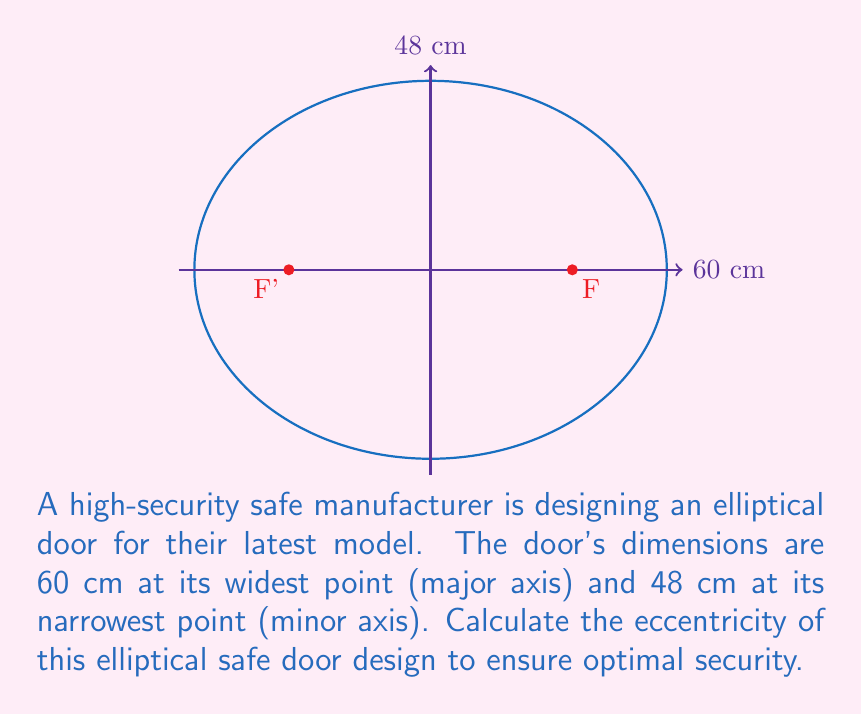Could you help me with this problem? Let's approach this step-by-step:

1) The eccentricity of an ellipse is given by the formula:

   $$e = \frac{\sqrt{a^2 - b^2}}{a}$$

   where $a$ is the semi-major axis and $b$ is the semi-minor axis.

2) From the given dimensions:
   - Major axis = 60 cm, so $a = 30$ cm
   - Minor axis = 48 cm, so $b = 24$ cm

3) Let's substitute these values into the formula:

   $$e = \frac{\sqrt{30^2 - 24^2}}{30}$$

4) Simplify under the square root:
   
   $$e = \frac{\sqrt{900 - 576}}{30} = \frac{\sqrt{324}}{30}$$

5) Simplify further:

   $$e = \frac{18}{30} = \frac{3}{5} = 0.6$$

Therefore, the eccentricity of the elliptical safe door is 0.6.
Answer: $e = 0.6$ 